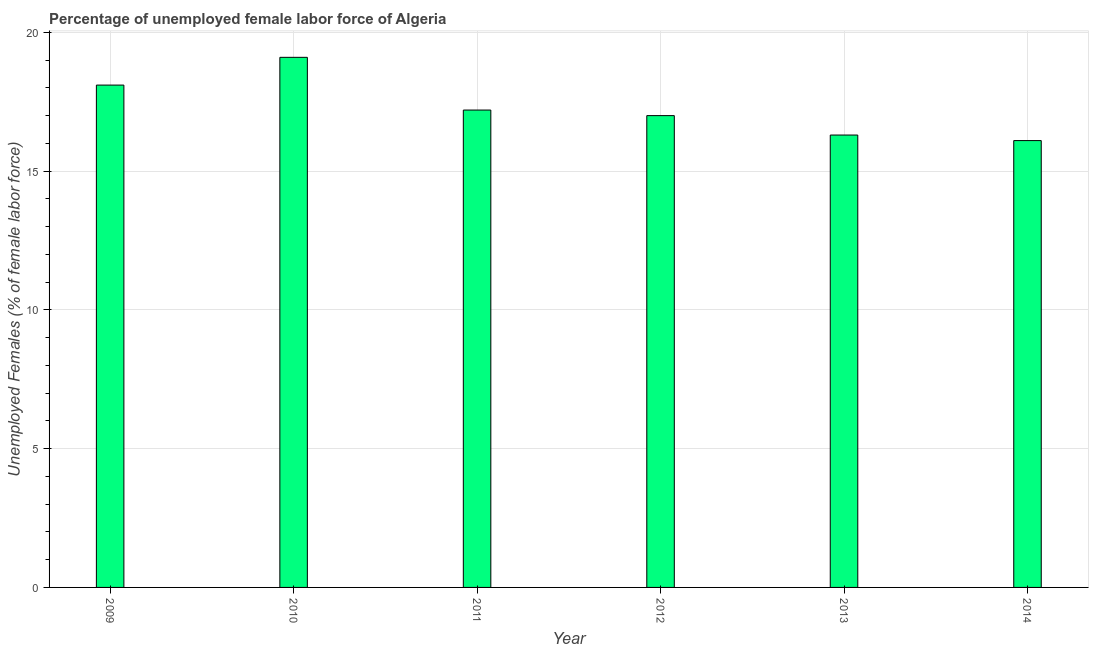Does the graph contain any zero values?
Offer a terse response. No. What is the title of the graph?
Make the answer very short. Percentage of unemployed female labor force of Algeria. What is the label or title of the Y-axis?
Offer a terse response. Unemployed Females (% of female labor force). What is the total unemployed female labour force in 2009?
Ensure brevity in your answer.  18.1. Across all years, what is the maximum total unemployed female labour force?
Provide a short and direct response. 19.1. Across all years, what is the minimum total unemployed female labour force?
Offer a terse response. 16.1. In which year was the total unemployed female labour force maximum?
Offer a very short reply. 2010. What is the sum of the total unemployed female labour force?
Provide a succinct answer. 103.8. What is the average total unemployed female labour force per year?
Your answer should be compact. 17.3. What is the median total unemployed female labour force?
Provide a short and direct response. 17.1. In how many years, is the total unemployed female labour force greater than 13 %?
Give a very brief answer. 6. What is the ratio of the total unemployed female labour force in 2010 to that in 2014?
Ensure brevity in your answer.  1.19. Is the difference between the total unemployed female labour force in 2011 and 2014 greater than the difference between any two years?
Your answer should be compact. No. Is the sum of the total unemployed female labour force in 2010 and 2014 greater than the maximum total unemployed female labour force across all years?
Provide a short and direct response. Yes. In how many years, is the total unemployed female labour force greater than the average total unemployed female labour force taken over all years?
Your answer should be very brief. 2. How many bars are there?
Provide a succinct answer. 6. What is the difference between two consecutive major ticks on the Y-axis?
Your answer should be compact. 5. Are the values on the major ticks of Y-axis written in scientific E-notation?
Provide a short and direct response. No. What is the Unemployed Females (% of female labor force) in 2009?
Provide a succinct answer. 18.1. What is the Unemployed Females (% of female labor force) of 2010?
Make the answer very short. 19.1. What is the Unemployed Females (% of female labor force) of 2011?
Provide a short and direct response. 17.2. What is the Unemployed Females (% of female labor force) of 2013?
Offer a terse response. 16.3. What is the Unemployed Females (% of female labor force) of 2014?
Provide a succinct answer. 16.1. What is the difference between the Unemployed Females (% of female labor force) in 2009 and 2010?
Ensure brevity in your answer.  -1. What is the difference between the Unemployed Females (% of female labor force) in 2009 and 2012?
Offer a terse response. 1.1. What is the difference between the Unemployed Females (% of female labor force) in 2009 and 2013?
Offer a terse response. 1.8. What is the difference between the Unemployed Females (% of female labor force) in 2009 and 2014?
Give a very brief answer. 2. What is the difference between the Unemployed Females (% of female labor force) in 2010 and 2012?
Ensure brevity in your answer.  2.1. What is the difference between the Unemployed Females (% of female labor force) in 2010 and 2013?
Your answer should be very brief. 2.8. What is the difference between the Unemployed Females (% of female labor force) in 2010 and 2014?
Give a very brief answer. 3. What is the difference between the Unemployed Females (% of female labor force) in 2011 and 2012?
Make the answer very short. 0.2. What is the difference between the Unemployed Females (% of female labor force) in 2012 and 2014?
Provide a short and direct response. 0.9. What is the difference between the Unemployed Females (% of female labor force) in 2013 and 2014?
Provide a short and direct response. 0.2. What is the ratio of the Unemployed Females (% of female labor force) in 2009 to that in 2010?
Your response must be concise. 0.95. What is the ratio of the Unemployed Females (% of female labor force) in 2009 to that in 2011?
Your answer should be very brief. 1.05. What is the ratio of the Unemployed Females (% of female labor force) in 2009 to that in 2012?
Offer a terse response. 1.06. What is the ratio of the Unemployed Females (% of female labor force) in 2009 to that in 2013?
Your answer should be very brief. 1.11. What is the ratio of the Unemployed Females (% of female labor force) in 2009 to that in 2014?
Give a very brief answer. 1.12. What is the ratio of the Unemployed Females (% of female labor force) in 2010 to that in 2011?
Give a very brief answer. 1.11. What is the ratio of the Unemployed Females (% of female labor force) in 2010 to that in 2012?
Ensure brevity in your answer.  1.12. What is the ratio of the Unemployed Females (% of female labor force) in 2010 to that in 2013?
Provide a short and direct response. 1.17. What is the ratio of the Unemployed Females (% of female labor force) in 2010 to that in 2014?
Your answer should be compact. 1.19. What is the ratio of the Unemployed Females (% of female labor force) in 2011 to that in 2013?
Give a very brief answer. 1.05. What is the ratio of the Unemployed Females (% of female labor force) in 2011 to that in 2014?
Your response must be concise. 1.07. What is the ratio of the Unemployed Females (% of female labor force) in 2012 to that in 2013?
Offer a terse response. 1.04. What is the ratio of the Unemployed Females (% of female labor force) in 2012 to that in 2014?
Your response must be concise. 1.06. What is the ratio of the Unemployed Females (% of female labor force) in 2013 to that in 2014?
Your answer should be very brief. 1.01. 